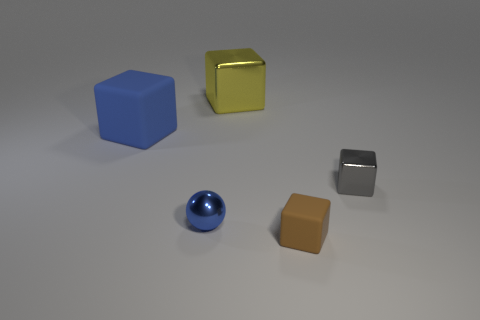Subtract 1 cubes. How many cubes are left? 3 Add 3 large brown matte blocks. How many objects exist? 8 Subtract all balls. How many objects are left? 4 Add 2 blue balls. How many blue balls exist? 3 Subtract 0 green balls. How many objects are left? 5 Subtract all tiny cubes. Subtract all big rubber things. How many objects are left? 2 Add 5 rubber objects. How many rubber objects are left? 7 